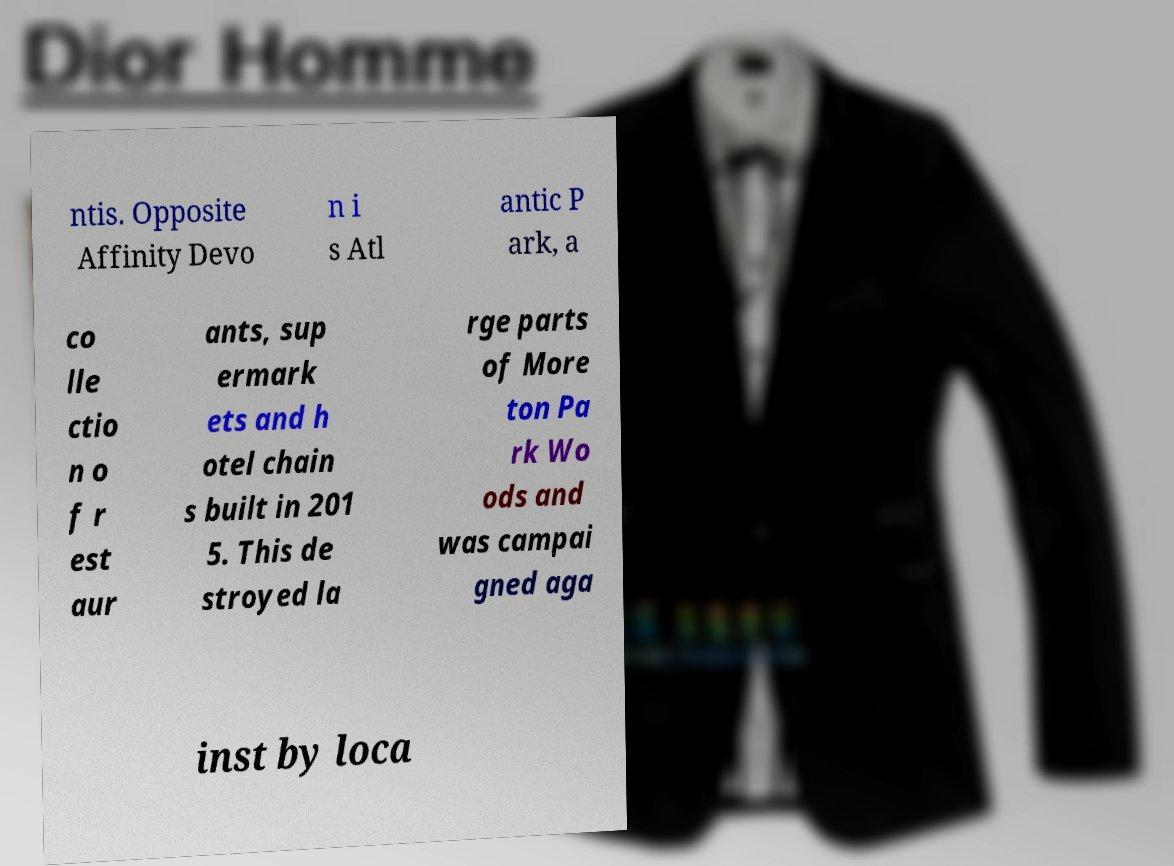Please read and relay the text visible in this image. What does it say? ntis. Opposite Affinity Devo n i s Atl antic P ark, a co lle ctio n o f r est aur ants, sup ermark ets and h otel chain s built in 201 5. This de stroyed la rge parts of More ton Pa rk Wo ods and was campai gned aga inst by loca 